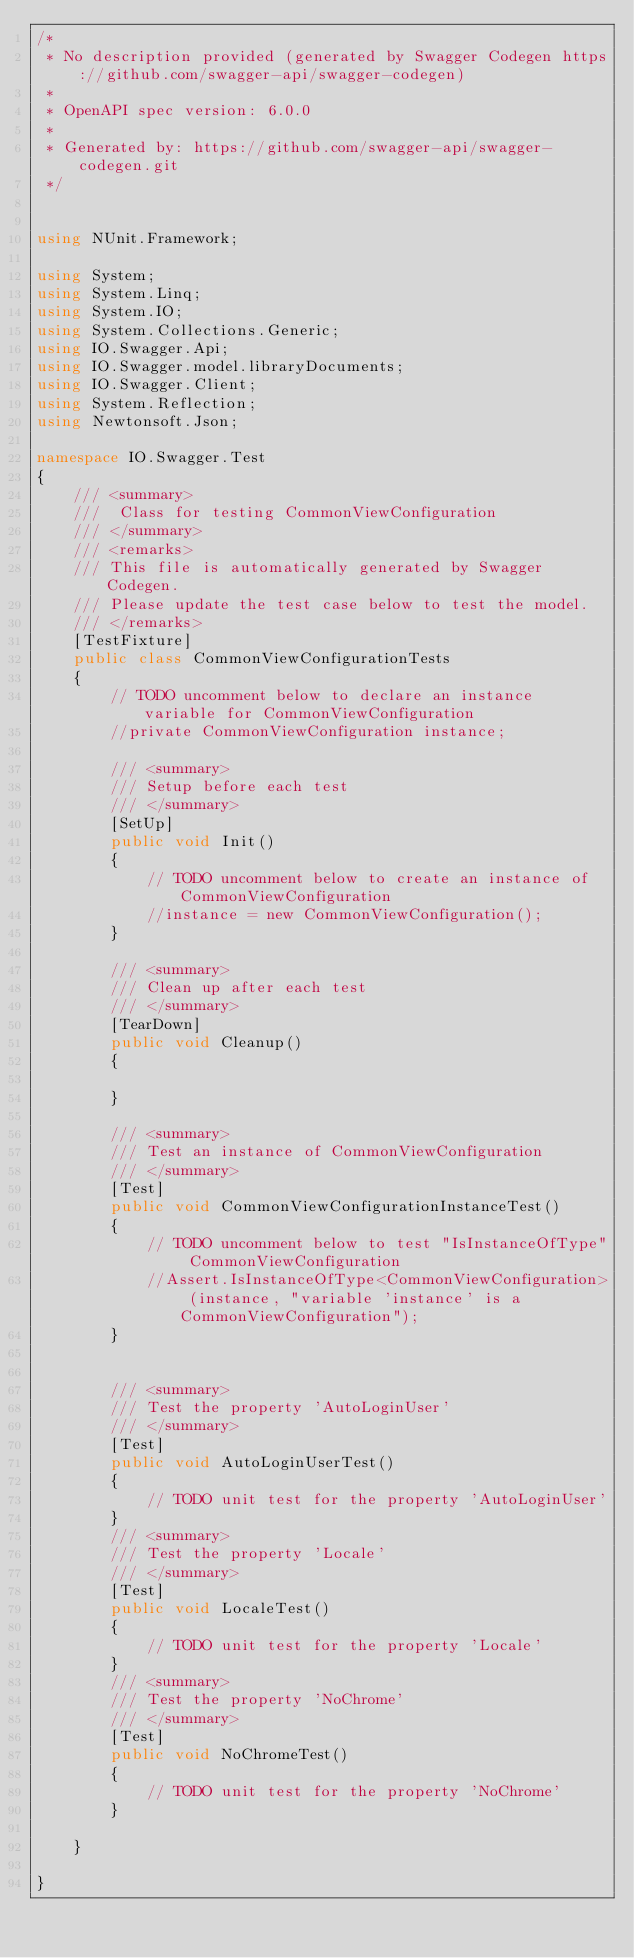Convert code to text. <code><loc_0><loc_0><loc_500><loc_500><_C#_>/* 
 * No description provided (generated by Swagger Codegen https://github.com/swagger-api/swagger-codegen)
 *
 * OpenAPI spec version: 6.0.0
 * 
 * Generated by: https://github.com/swagger-api/swagger-codegen.git
 */


using NUnit.Framework;

using System;
using System.Linq;
using System.IO;
using System.Collections.Generic;
using IO.Swagger.Api;
using IO.Swagger.model.libraryDocuments;
using IO.Swagger.Client;
using System.Reflection;
using Newtonsoft.Json;

namespace IO.Swagger.Test
{
    /// <summary>
    ///  Class for testing CommonViewConfiguration
    /// </summary>
    /// <remarks>
    /// This file is automatically generated by Swagger Codegen.
    /// Please update the test case below to test the model.
    /// </remarks>
    [TestFixture]
    public class CommonViewConfigurationTests
    {
        // TODO uncomment below to declare an instance variable for CommonViewConfiguration
        //private CommonViewConfiguration instance;

        /// <summary>
        /// Setup before each test
        /// </summary>
        [SetUp]
        public void Init()
        {
            // TODO uncomment below to create an instance of CommonViewConfiguration
            //instance = new CommonViewConfiguration();
        }

        /// <summary>
        /// Clean up after each test
        /// </summary>
        [TearDown]
        public void Cleanup()
        {

        }

        /// <summary>
        /// Test an instance of CommonViewConfiguration
        /// </summary>
        [Test]
        public void CommonViewConfigurationInstanceTest()
        {
            // TODO uncomment below to test "IsInstanceOfType" CommonViewConfiguration
            //Assert.IsInstanceOfType<CommonViewConfiguration> (instance, "variable 'instance' is a CommonViewConfiguration");
        }


        /// <summary>
        /// Test the property 'AutoLoginUser'
        /// </summary>
        [Test]
        public void AutoLoginUserTest()
        {
            // TODO unit test for the property 'AutoLoginUser'
        }
        /// <summary>
        /// Test the property 'Locale'
        /// </summary>
        [Test]
        public void LocaleTest()
        {
            // TODO unit test for the property 'Locale'
        }
        /// <summary>
        /// Test the property 'NoChrome'
        /// </summary>
        [Test]
        public void NoChromeTest()
        {
            // TODO unit test for the property 'NoChrome'
        }

    }

}
</code> 